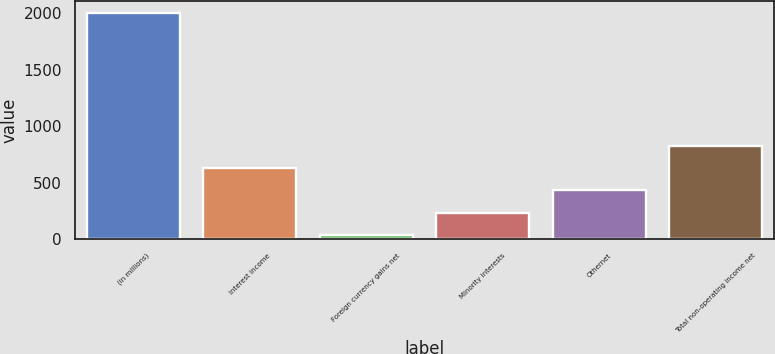Convert chart. <chart><loc_0><loc_0><loc_500><loc_500><bar_chart><fcel>(in millions)<fcel>Interest income<fcel>Foreign currency gains net<fcel>Minority interests<fcel>Othernet<fcel>Total non-operating income net<nl><fcel>2006<fcel>629.1<fcel>39<fcel>235.7<fcel>432.4<fcel>825.8<nl></chart> 